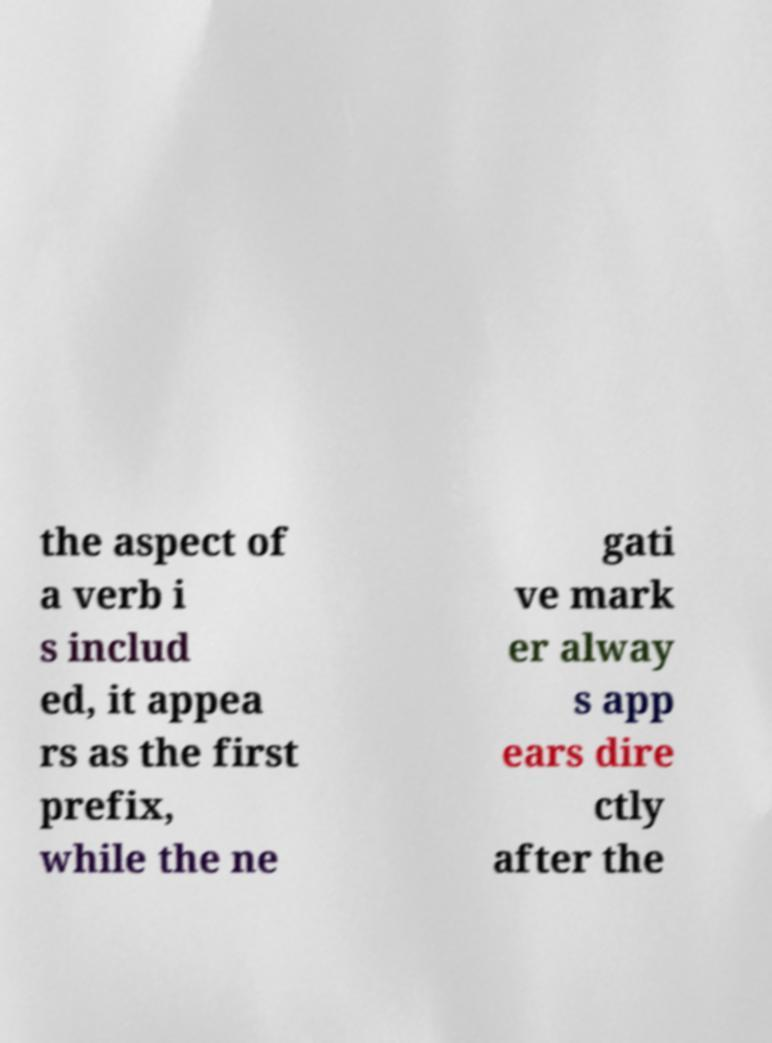For documentation purposes, I need the text within this image transcribed. Could you provide that? the aspect of a verb i s includ ed, it appea rs as the first prefix, while the ne gati ve mark er alway s app ears dire ctly after the 